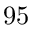<formula> <loc_0><loc_0><loc_500><loc_500>9 5</formula> 